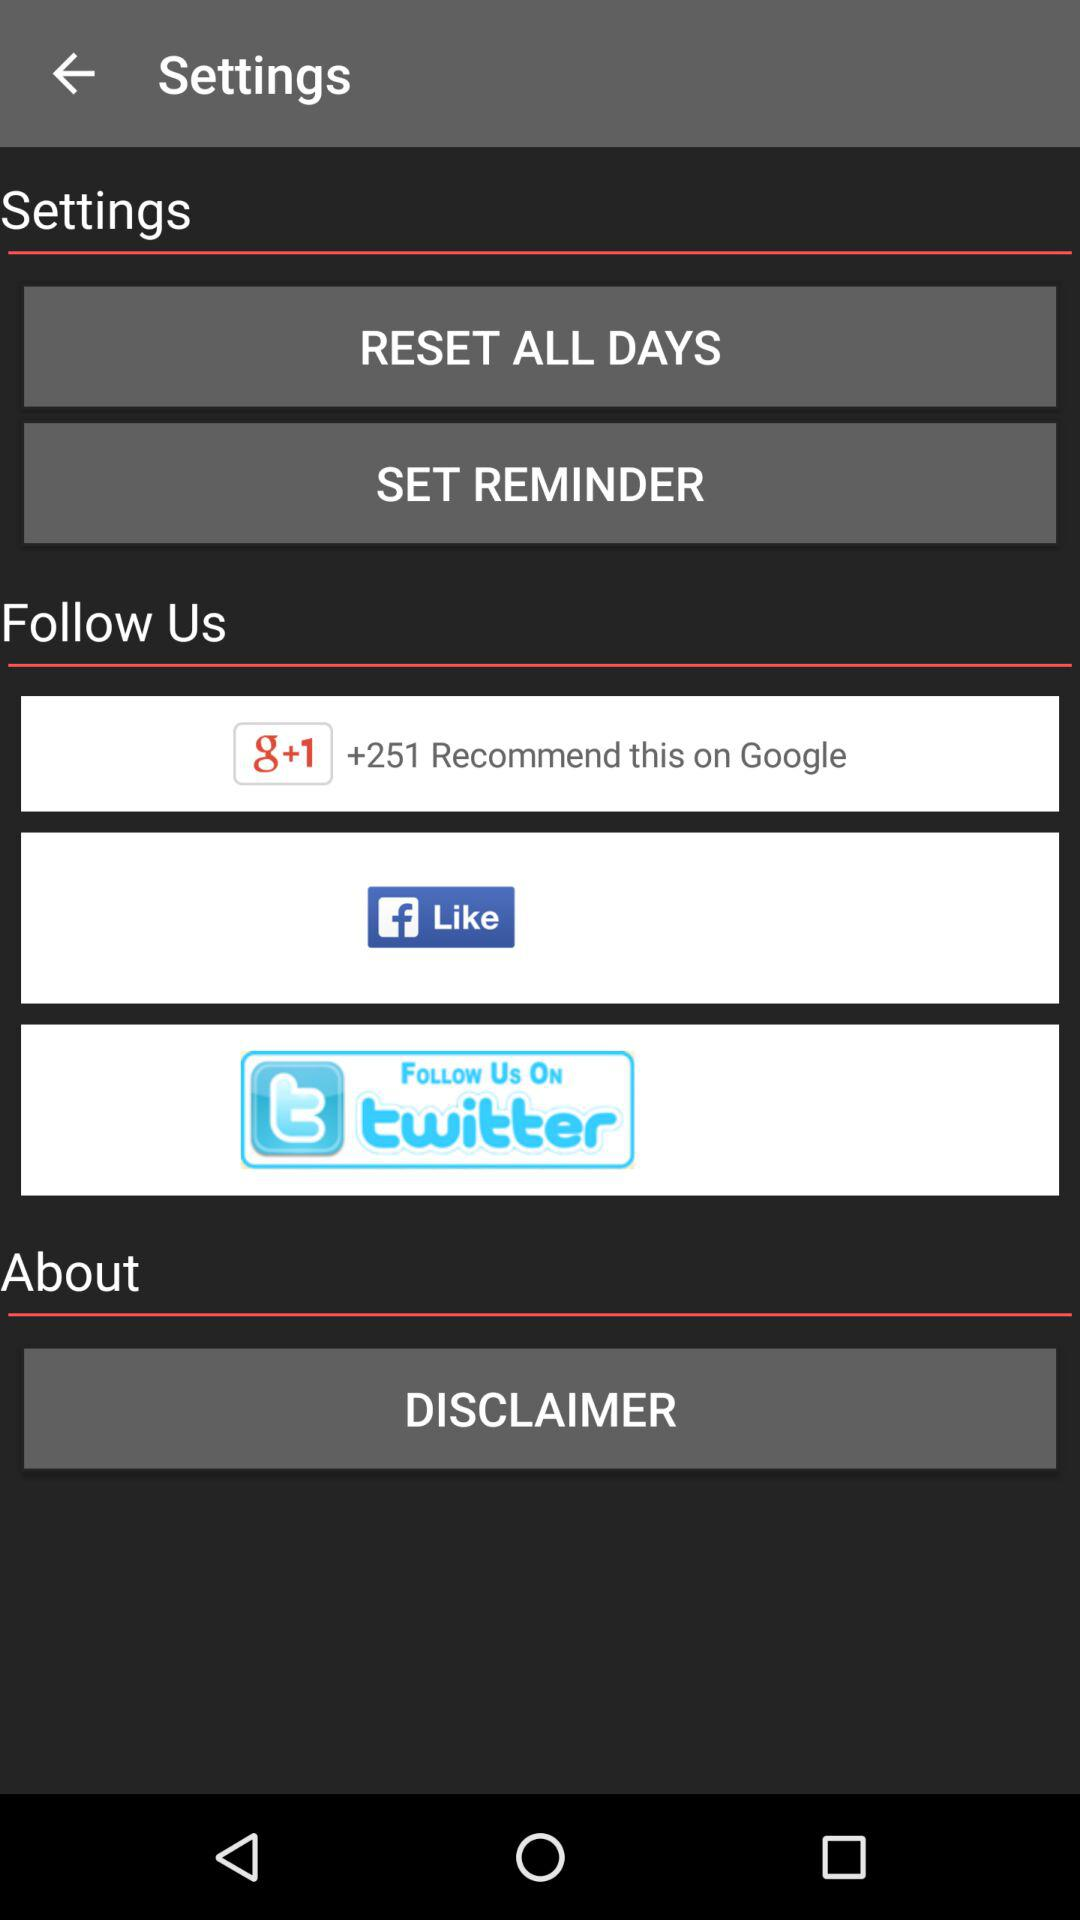Which days of the week are to be reset?
When the provided information is insufficient, respond with <no answer>. <no answer> 